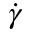<formula> <loc_0><loc_0><loc_500><loc_500>\dot { \gamma }</formula> 